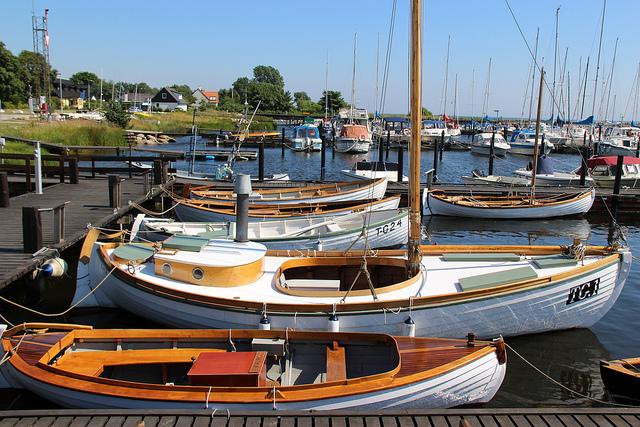Does it appear to be high or low tide?
Short answer required. Low. How many boats are there?
Concise answer only. 15. Are the boats owned?
Quick response, please. Yes. 